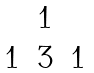<formula> <loc_0><loc_0><loc_500><loc_500>\begin{matrix} & 1 & \\ 1 & 3 & 1 \end{matrix}</formula> 